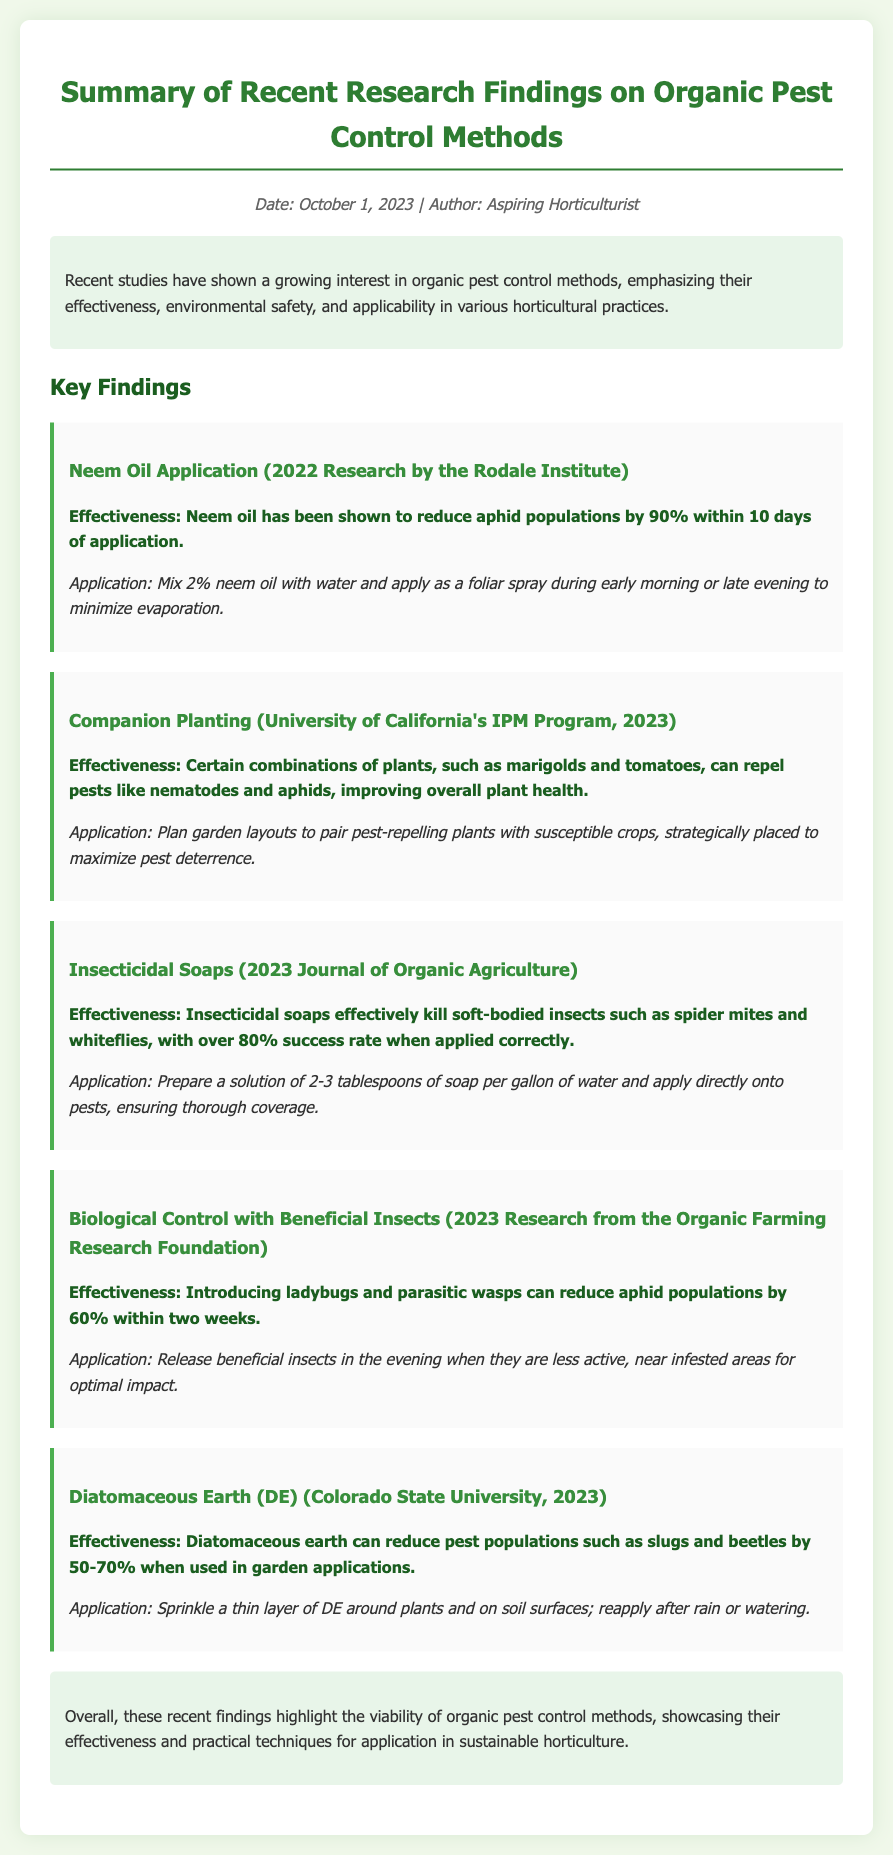What is the date of the document? The date of the document is stated in the metadata section.
Answer: October 1, 2023 Who conducted research on Neem Oil Application? The research on Neem Oil Application was conducted by the Rodale Institute.
Answer: Rodale Institute What is the effectiveness rate of Insecticidal Soaps? The effectiveness rate of Insecticidal Soaps is mentioned in the findings section.
Answer: over 80% What pest can be reduced by introducing ladybugs? The document mentions specifically which pest populations can be reduced by ladybugs.
Answer: aphid populations What is the optimum time to apply neem oil? The document specifies the best times for neem oil application.
Answer: early morning or late evening Which plants are mentioned for companion planting? The document gives examples of plants that can be used in companion planting.
Answer: marigolds and tomatoes What percentage reduction of pest populations does Diatomaceous Earth achieve? The effectiveness of Diatomaceous Earth is quantified in the findings.
Answer: 50-70% What is a practical application method for insecticidal soaps? A specific preparation method for applying insecticidal soaps is outlined in the document.
Answer: 2-3 tablespoons of soap per gallon of water What do recent findings emphasize about organic pest control methods? The document highlights the overall conclusion drawn from recent findings.
Answer: viability of organic pest control methods 